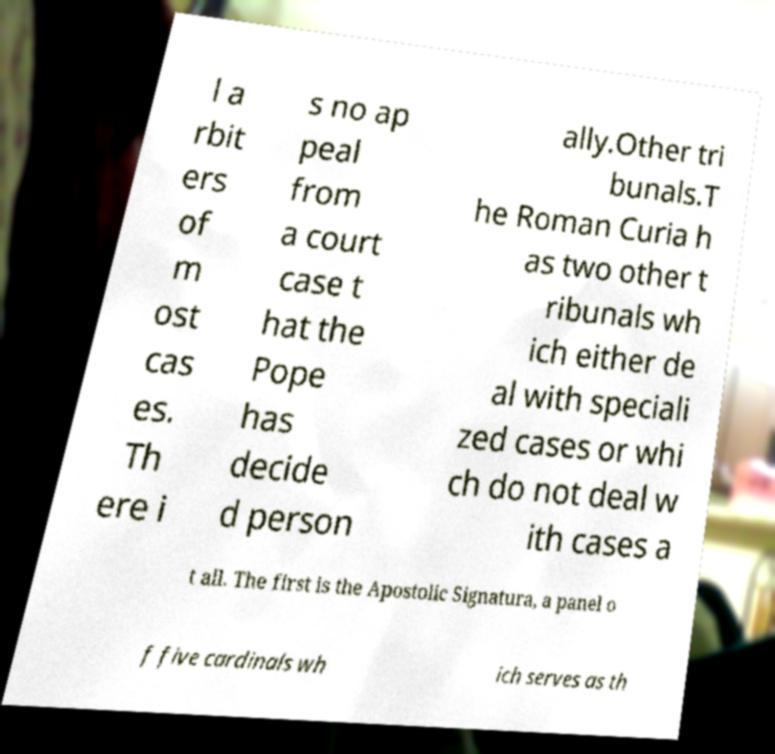Can you read and provide the text displayed in the image?This photo seems to have some interesting text. Can you extract and type it out for me? l a rbit ers of m ost cas es. Th ere i s no ap peal from a court case t hat the Pope has decide d person ally.Other tri bunals.T he Roman Curia h as two other t ribunals wh ich either de al with speciali zed cases or whi ch do not deal w ith cases a t all. The first is the Apostolic Signatura, a panel o f five cardinals wh ich serves as th 